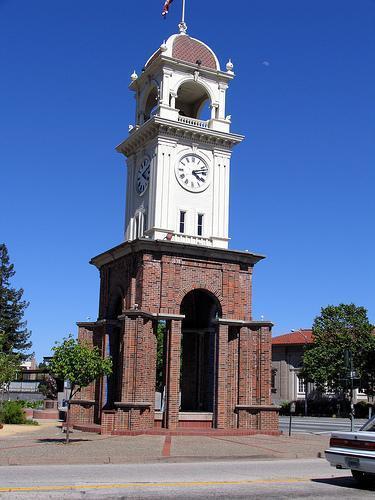How many cars are in this photo?
Give a very brief answer. 1. How many clocks are on the tower?
Give a very brief answer. 1. How many flags are on top of the tower?
Give a very brief answer. 1. 